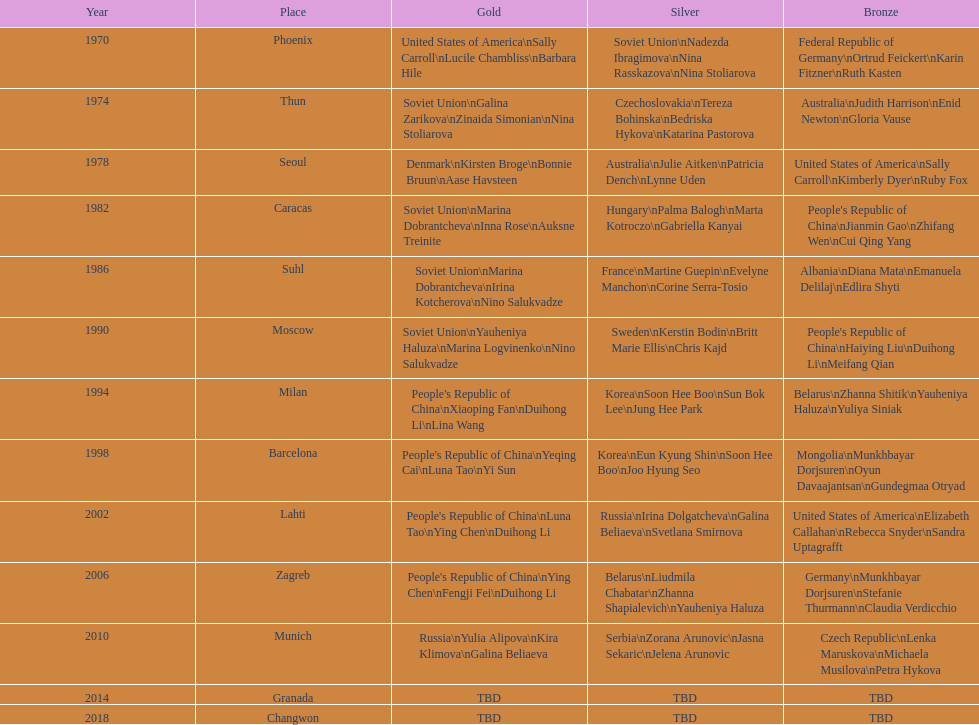What is the number of total bronze medals that germany has won? 1. 